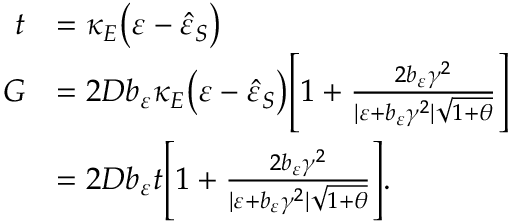Convert formula to latex. <formula><loc_0><loc_0><loc_500><loc_500>\begin{array} { r l } { t } & { = \kappa _ { E } \left ( \varepsilon - \hat { \varepsilon } _ { S } \right ) } \\ { G } & { = 2 D b _ { \varepsilon } \kappa _ { E } \left ( \varepsilon - \hat { \varepsilon } _ { S } \right ) \left [ 1 + \frac { 2 b _ { \varepsilon } \gamma ^ { 2 } } { | \varepsilon + b _ { \varepsilon } \gamma ^ { 2 } | \sqrt { 1 + \theta } } \right ] } \\ & { = 2 D b _ { \varepsilon } t \left [ 1 + \frac { 2 b _ { \varepsilon } \gamma ^ { 2 } } { | \varepsilon + b _ { \varepsilon } \gamma ^ { 2 } | \sqrt { 1 + \theta } } \right ] . } \end{array}</formula> 